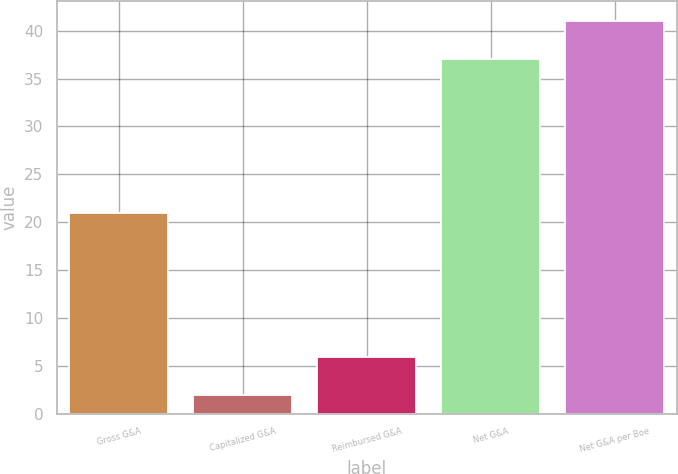Convert chart. <chart><loc_0><loc_0><loc_500><loc_500><bar_chart><fcel>Gross G&A<fcel>Capitalized G&A<fcel>Reimbursed G&A<fcel>Net G&A<fcel>Net G&A per Boe<nl><fcel>21<fcel>2<fcel>5.9<fcel>37<fcel>41<nl></chart> 